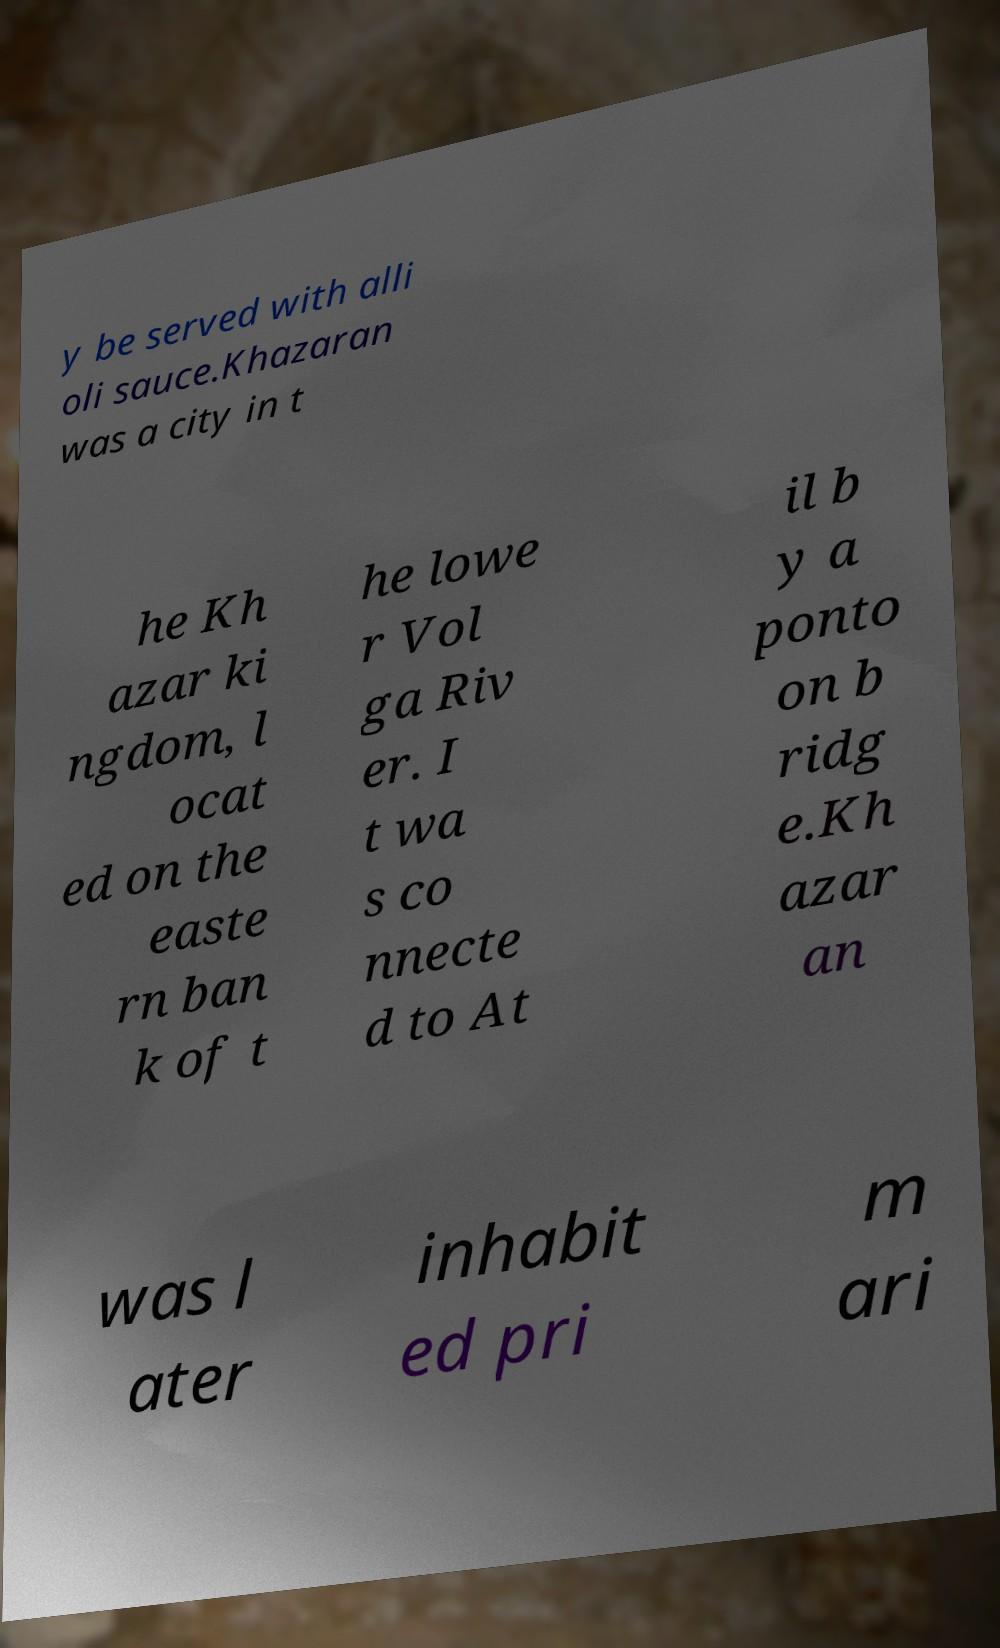For documentation purposes, I need the text within this image transcribed. Could you provide that? y be served with alli oli sauce.Khazaran was a city in t he Kh azar ki ngdom, l ocat ed on the easte rn ban k of t he lowe r Vol ga Riv er. I t wa s co nnecte d to At il b y a ponto on b ridg e.Kh azar an was l ater inhabit ed pri m ari 